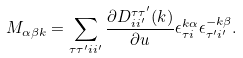Convert formula to latex. <formula><loc_0><loc_0><loc_500><loc_500>M _ { \alpha \beta { k } } = \sum _ { \tau \tau ^ { \prime } i i ^ { \prime } } \frac { { \partial } { D ^ { \tau \tau ^ { \prime } } _ { i i ^ { \prime } } ( { k } ) } } { { \partial } u } \epsilon ^ { { k } \alpha } _ { { \tau } i } \epsilon ^ { { - k } \beta } _ { { \tau ^ { \prime } } i ^ { \prime } } .</formula> 